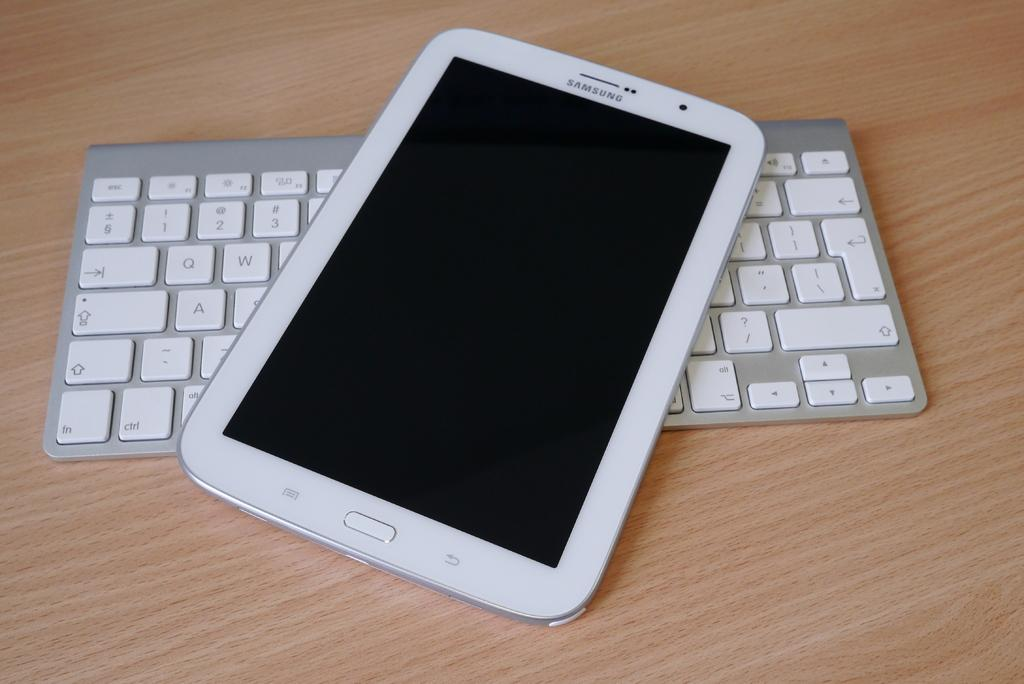What is the main structure in the image? There is a wooden platform in the image. What is placed on the wooden platform? There is a keyboard and a mobile on the wooden platform. What can be identified on the mobile? The mobile has a company name at the top. What type of substance is being used to clean the edge of the wooden platform in the image? There is no substance or cleaning activity visible in the image. 